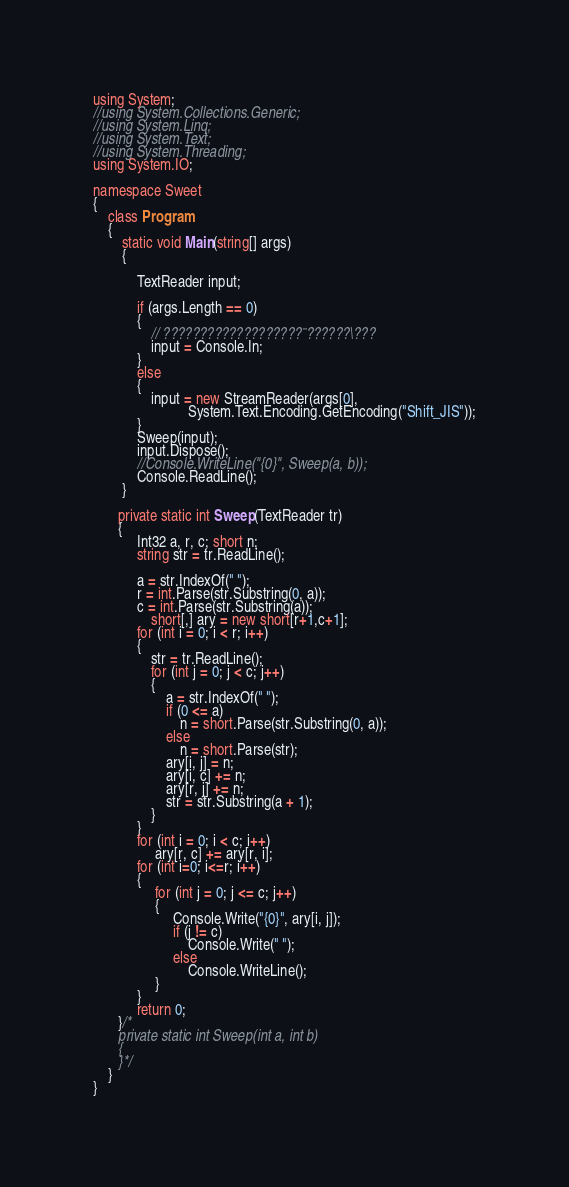Convert code to text. <code><loc_0><loc_0><loc_500><loc_500><_C#_>using System;
//using System.Collections.Generic;
//using System.Linq;
//using System.Text;
//using System.Threading;
using System.IO;

namespace Sweet
{
    class Program
    {
        static void Main(string[] args)
        {
            
            TextReader input;

            if (args.Length == 0)
            {
                // ???????????????????¨??????\???
                input = Console.In;
            }
            else
            {
                input = new StreamReader(args[0],
                          System.Text.Encoding.GetEncoding("Shift_JIS"));
            }
            Sweep(input);
            input.Dispose();
            //Console.WriteLine("{0}", Sweep(a, b));
            Console.ReadLine();
        }
        
       private static int Sweep(TextReader tr)
       {
            Int32 a, r, c; short n;
            string str = tr.ReadLine();
      
            a = str.IndexOf(" ");
            r = int.Parse(str.Substring(0, a));
            c = int.Parse(str.Substring(a));
                short[,] ary = new short[r+1,c+1];
            for (int i = 0; i < r; i++)
            {
                str = tr.ReadLine();
                for (int j = 0; j < c; j++)
                {
                    a = str.IndexOf(" ");
                    if (0 <= a)
                        n = short.Parse(str.Substring(0, a));
                    else
                        n = short.Parse(str);
                    ary[i, j] = n;
                    ary[i, c] += n;
                    ary[r, j] += n;
                    str = str.Substring(a + 1);
                }
            }
            for (int i = 0; i < c; i++)
                 ary[r, c] += ary[r, i];
            for (int i=0; i<=r; i++)
            {
                 for (int j = 0; j <= c; j++)
                 {
                      Console.Write("{0}", ary[i, j]);
                      if (j != c)
                          Console.Write(" ");
                      else
                          Console.WriteLine();
                 }
            }
            return 0;
       }/*
       private static int Sweep(int a, int b)
       {
       }*/
    }
}</code> 